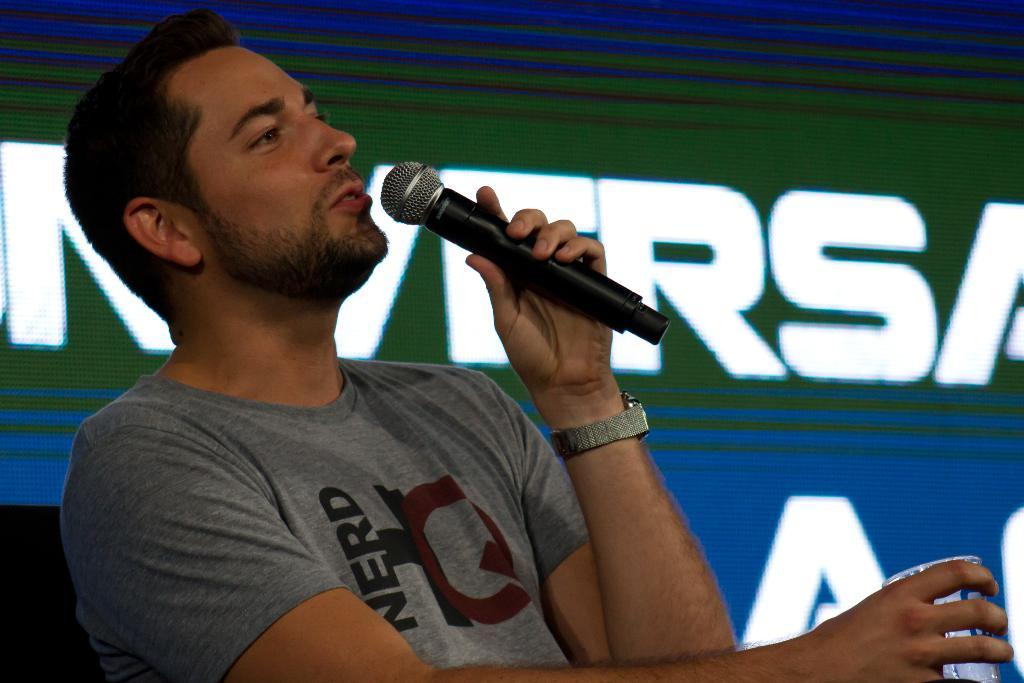What is the person in the image wearing on their upper body? The person is wearing a grey shirt. What is the person holding in their hand? The person is holding a microphone and a glass. What is the person doing in the image? The person is talking and holding a microphone. What can be seen in the background of the image? There is a banner visible in the image. What accessory is the person wearing on their wrist? The person is wearing a watch. Can you see any bite marks on the microphone in the image? There are no bite marks visible on the microphone in the image. What type of mask is the person wearing in the image? There is no mask present in the image. 